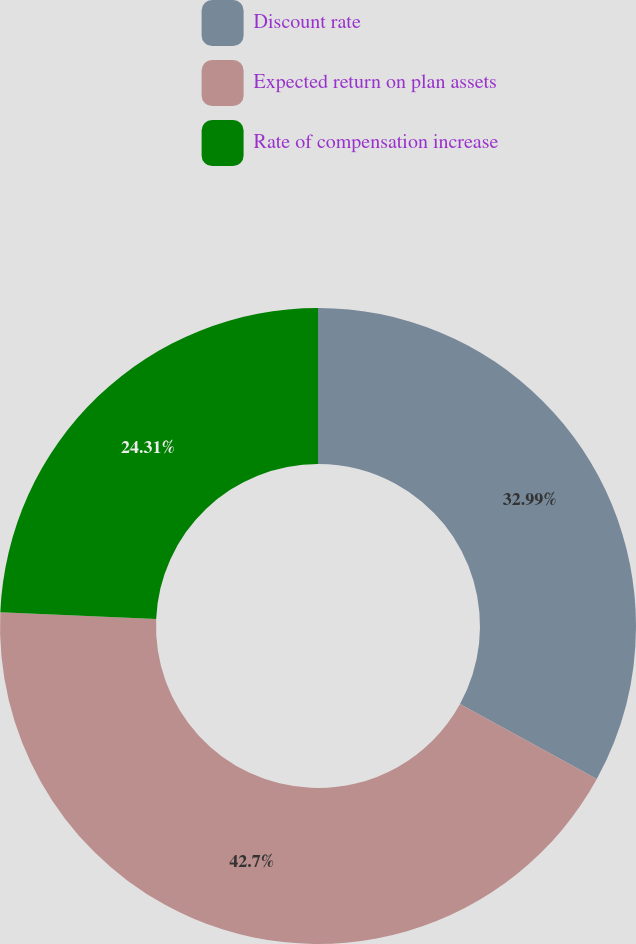Convert chart. <chart><loc_0><loc_0><loc_500><loc_500><pie_chart><fcel>Discount rate<fcel>Expected return on plan assets<fcel>Rate of compensation increase<nl><fcel>32.99%<fcel>42.71%<fcel>24.31%<nl></chart> 